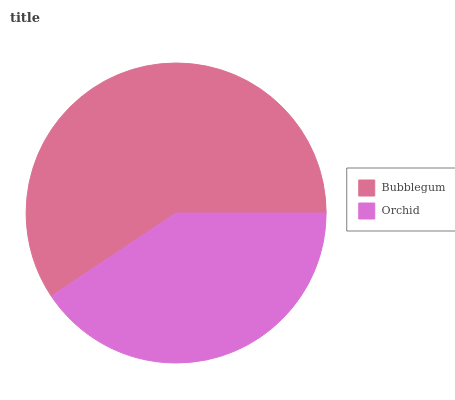Is Orchid the minimum?
Answer yes or no. Yes. Is Bubblegum the maximum?
Answer yes or no. Yes. Is Orchid the maximum?
Answer yes or no. No. Is Bubblegum greater than Orchid?
Answer yes or no. Yes. Is Orchid less than Bubblegum?
Answer yes or no. Yes. Is Orchid greater than Bubblegum?
Answer yes or no. No. Is Bubblegum less than Orchid?
Answer yes or no. No. Is Bubblegum the high median?
Answer yes or no. Yes. Is Orchid the low median?
Answer yes or no. Yes. Is Orchid the high median?
Answer yes or no. No. Is Bubblegum the low median?
Answer yes or no. No. 